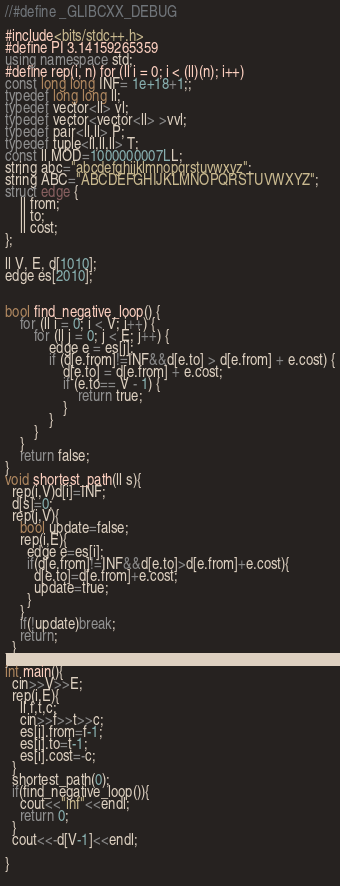Convert code to text. <code><loc_0><loc_0><loc_500><loc_500><_C++_>//#define _GLIBCXX_DEBUG

#include<bits/stdc++.h>
#define PI 3.14159265359
using namespace std;
#define rep(i, n) for (ll i = 0; i < (ll)(n); i++)
const long long INF= 1e+18+1;;
typedef long long ll;
typedef vector<ll> vl;
typedef vector<vector<ll> >vvl;
typedef pair<ll,ll> P;
typedef tuple<ll,ll,ll> T;
const ll MOD=1000000007LL;
string abc="abcdefghijklmnopqrstuvwxyz";
string ABC="ABCDEFGHIJKLMNOPQRSTUVWXYZ";
struct edge {
    ll from;
    ll to;
    ll cost;
};

ll V, E, d[1010];
edge es[2010];


bool find_negative_loop() {
    for (ll i = 0; i < V; i++) {
        for (ll j = 0; j < E; j++) {
            edge e = es[j];
            if (d[e.from]!=INF&&d[e.to] > d[e.from] + e.cost) {
                d[e.to] = d[e.from] + e.cost;
                if (e.to== V - 1) {
                    return true;
                }
            }
        }
    }
    return false;
}
void shortest_path(ll s){
  rep(i,V)d[i]=INF;
  d[s]=0;
  rep(j,V){
    bool update=false;
    rep(i,E){
      edge e=es[i];
      if(d[e.from]!=INF&&d[e.to]>d[e.from]+e.cost){
        d[e.to]=d[e.from]+e.cost;
        update=true;
      }
    }
    if(!update)break;
    return;
  }
}
int main(){
  cin>>V>>E;
  rep(i,E){
    ll f,t,c;
    cin>>f>>t>>c;
    es[i].from=f-1;
    es[i].to=t-1;
    es[i].cost=-c;
  }
  shortest_path(0);
  if(find_negative_loop()){
    cout<<"inf"<<endl;
    return 0;
  }
  cout<<-d[V-1]<<endl;
  
}
  
</code> 